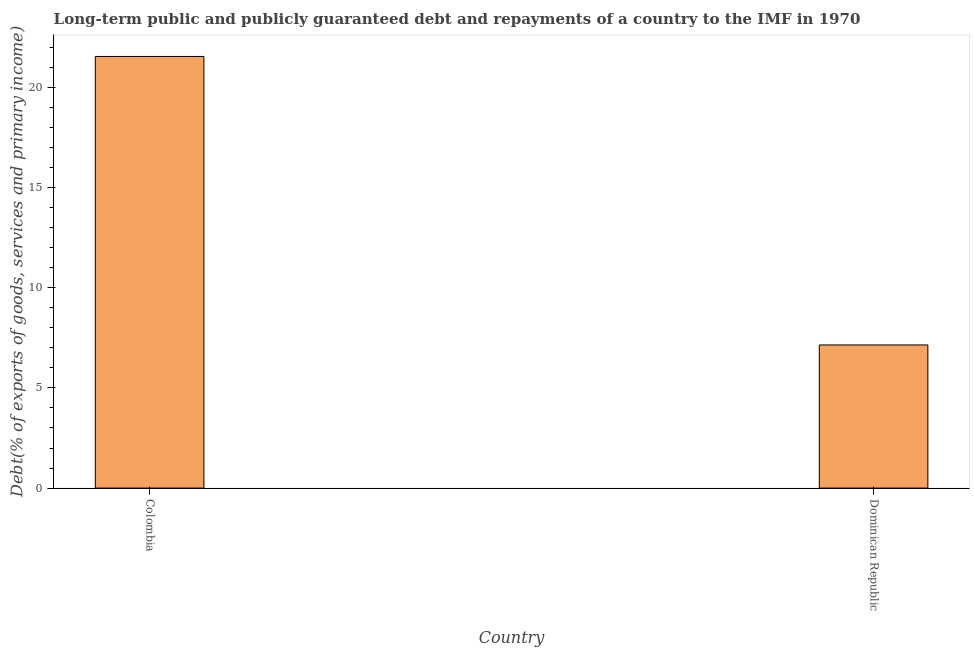Does the graph contain any zero values?
Ensure brevity in your answer.  No. Does the graph contain grids?
Offer a very short reply. No. What is the title of the graph?
Ensure brevity in your answer.  Long-term public and publicly guaranteed debt and repayments of a country to the IMF in 1970. What is the label or title of the X-axis?
Offer a very short reply. Country. What is the label or title of the Y-axis?
Offer a terse response. Debt(% of exports of goods, services and primary income). What is the debt service in Dominican Republic?
Provide a short and direct response. 7.14. Across all countries, what is the maximum debt service?
Offer a very short reply. 21.53. Across all countries, what is the minimum debt service?
Your answer should be very brief. 7.14. In which country was the debt service maximum?
Offer a very short reply. Colombia. In which country was the debt service minimum?
Ensure brevity in your answer.  Dominican Republic. What is the sum of the debt service?
Provide a succinct answer. 28.68. What is the difference between the debt service in Colombia and Dominican Republic?
Your response must be concise. 14.39. What is the average debt service per country?
Offer a terse response. 14.34. What is the median debt service?
Your answer should be compact. 14.34. What is the ratio of the debt service in Colombia to that in Dominican Republic?
Your answer should be very brief. 3.02. Is the debt service in Colombia less than that in Dominican Republic?
Offer a very short reply. No. In how many countries, is the debt service greater than the average debt service taken over all countries?
Provide a succinct answer. 1. How many bars are there?
Offer a terse response. 2. How many countries are there in the graph?
Give a very brief answer. 2. What is the Debt(% of exports of goods, services and primary income) in Colombia?
Provide a short and direct response. 21.53. What is the Debt(% of exports of goods, services and primary income) of Dominican Republic?
Your response must be concise. 7.14. What is the difference between the Debt(% of exports of goods, services and primary income) in Colombia and Dominican Republic?
Keep it short and to the point. 14.39. What is the ratio of the Debt(% of exports of goods, services and primary income) in Colombia to that in Dominican Republic?
Provide a short and direct response. 3.02. 